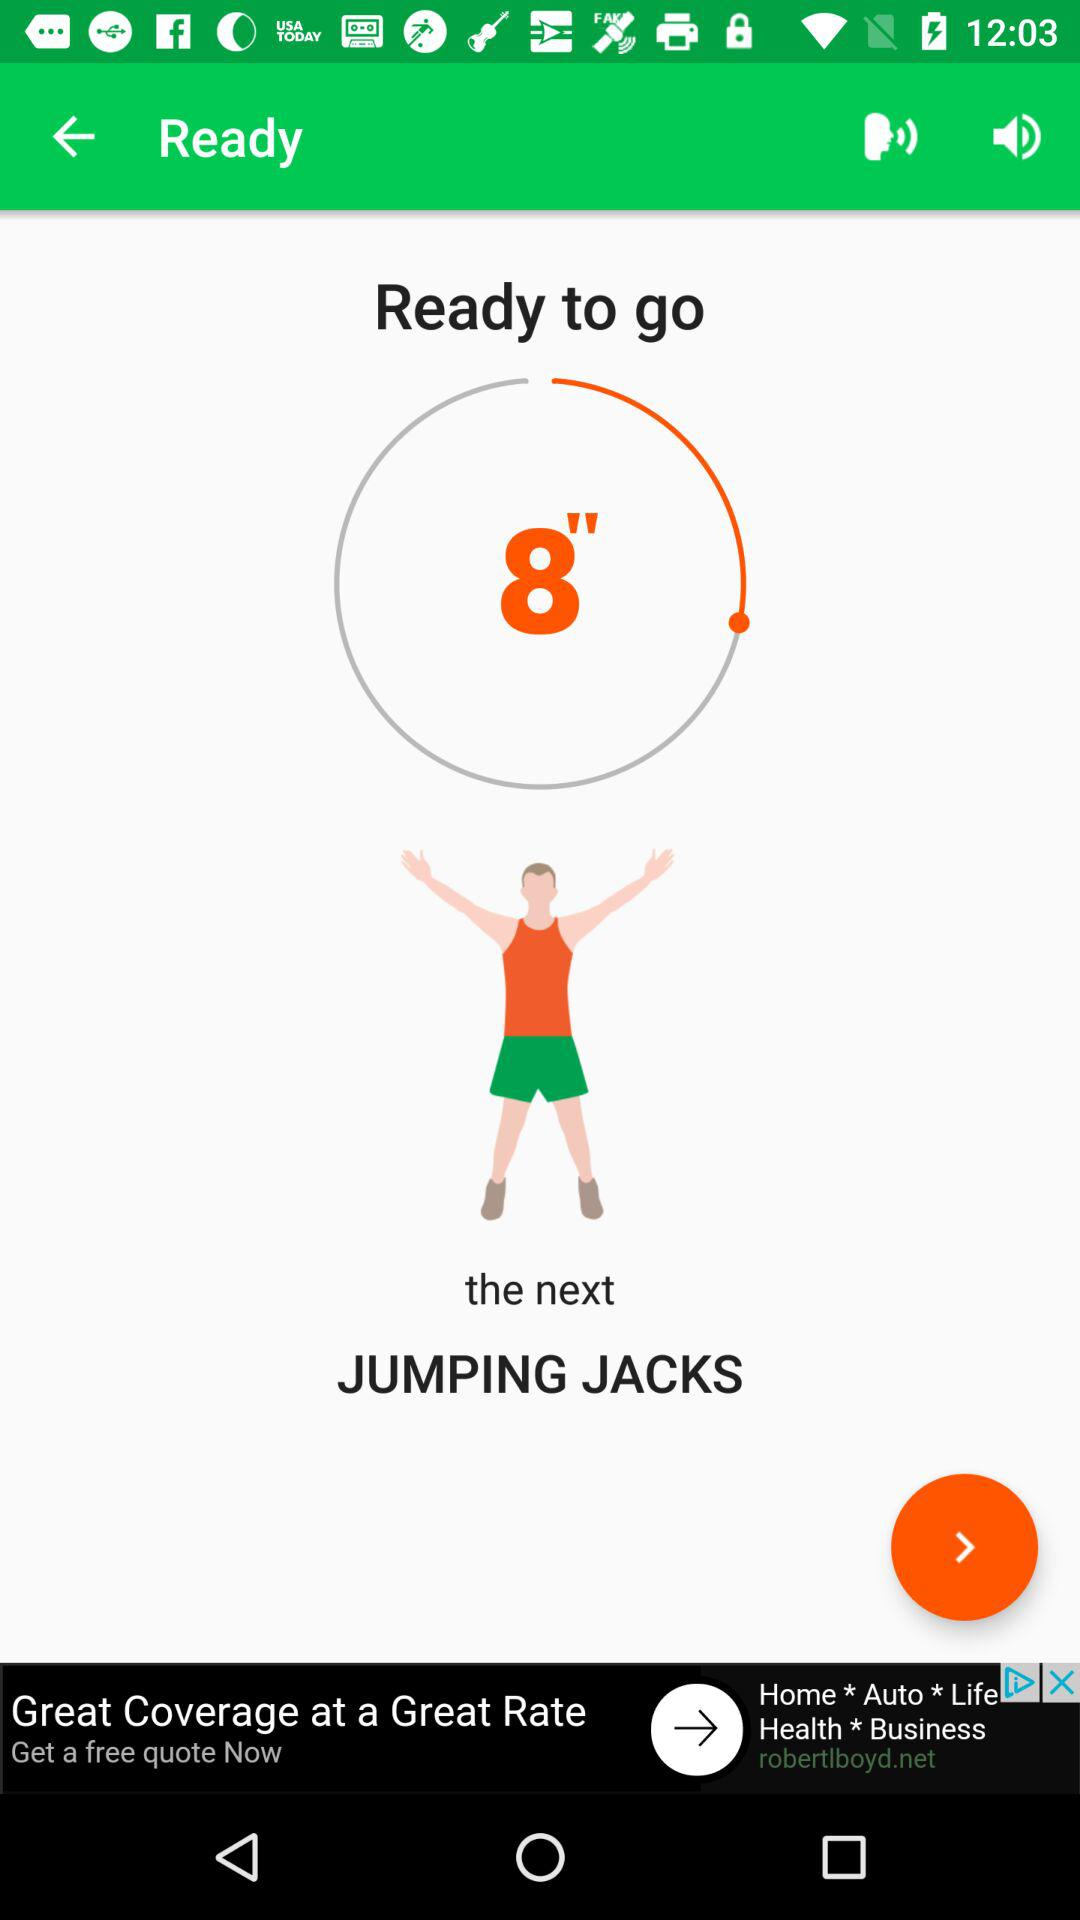How many volume states are there?
Answer the question using a single word or phrase. 2 